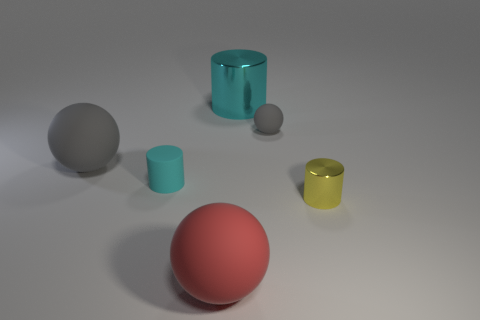Subtract all tiny yellow cylinders. How many cylinders are left? 2 Add 4 red rubber spheres. How many objects exist? 10 Subtract all red spheres. How many spheres are left? 2 Subtract 2 balls. How many balls are left? 1 Subtract 0 brown blocks. How many objects are left? 6 Subtract all green cylinders. Subtract all cyan spheres. How many cylinders are left? 3 Subtract all purple cylinders. How many brown balls are left? 0 Subtract all large cyan shiny cylinders. Subtract all rubber balls. How many objects are left? 2 Add 2 small gray things. How many small gray things are left? 3 Add 6 big gray metallic spheres. How many big gray metallic spheres exist? 6 